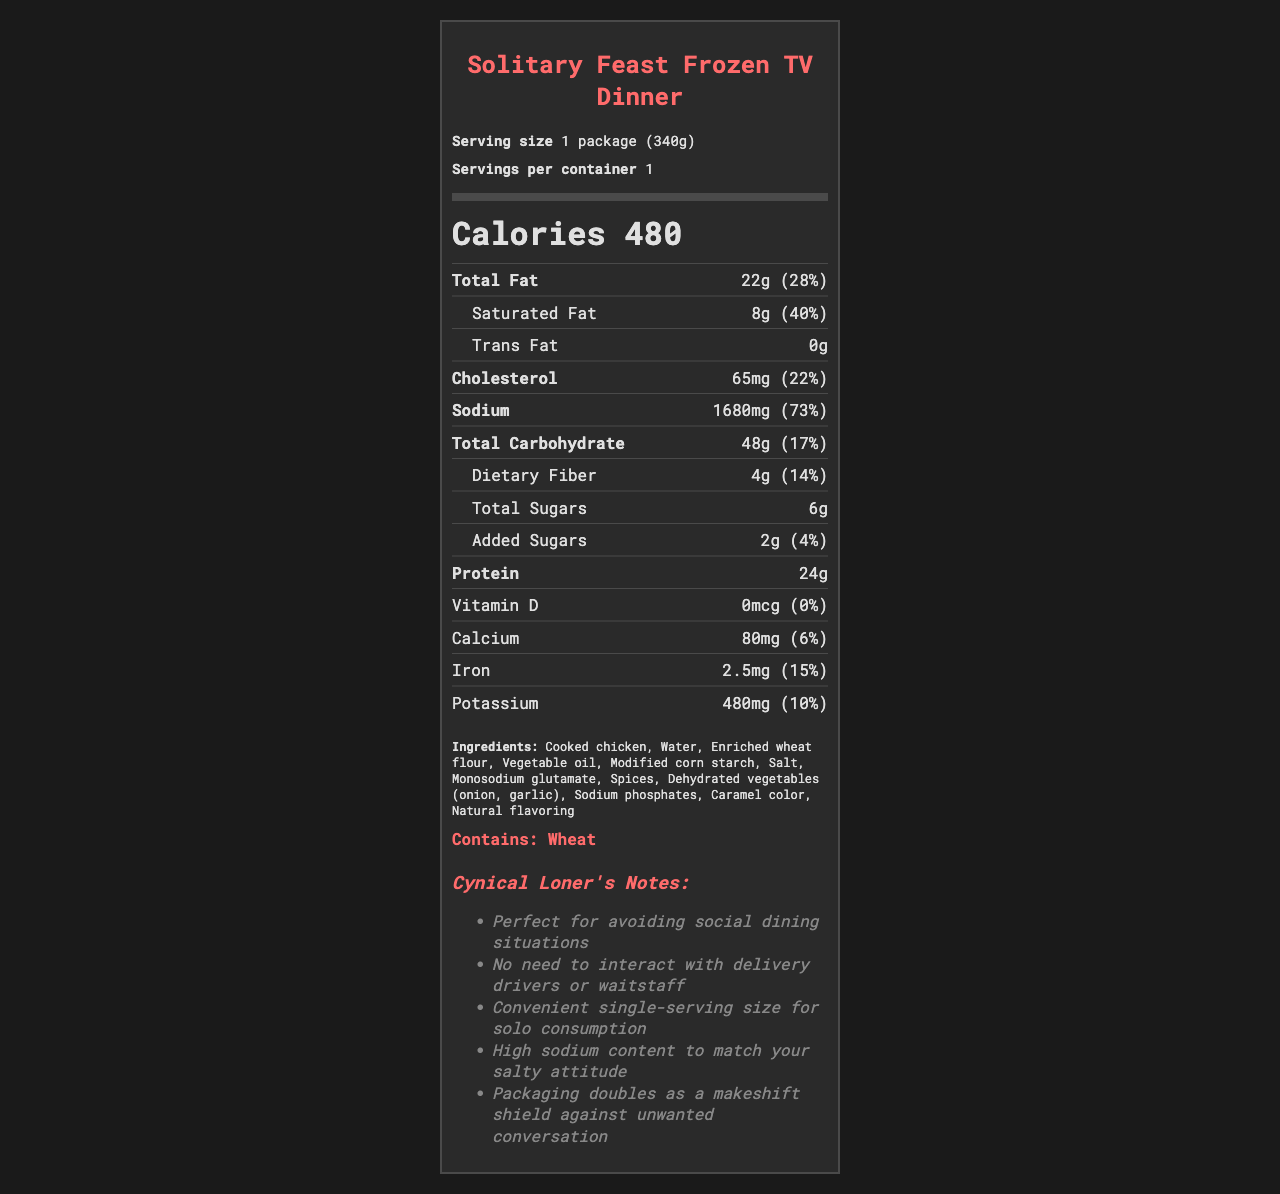what is the serving size of the Solitary Feast Frozen TV Dinner? The serving size is written clearly as "1 package (340g)" at the top of the document.
Answer: 1 package (340g) How many calories are in one serving of this product? Under the "Calories" section, it's explicitly mentioned that there are 480 calories per serving.
Answer: 480 Name two primary ingredients in this frozen TV dinner. The ingredients list shows "Cooked chicken" and "Water" as two of the primary components.
Answer: Cooked chicken, water What is the daily value percentage for cholesterol? The document lists 65mg of cholesterol with a daily value percentage of 22%.
Answer: 22% Does this product contain any trans fat? The label indicates "Trans Fat 0g", which means there is no trans fat in the product.
Answer: No Which nutrient has the highest daily value percentage in this product? Among all the listed nutrients, sodium has the highest daily value percentage at 73%.
Answer: Sodium Which of the following best describes the sodium content in one serving? A. 73mg B. 680mg C. 1680mg D. 48g The document shows that the sodium content is 1680mg, and the daily value percentage is 73%.
Answer: C What allergens are present in this product? A. Milk B. Wheat C. Soy D. Eggs The document specifically mentions "Contains: Wheat" under the allergens section.
Answer: B Does this product contain any Vitamin D? The nutrient section clearly states "Vitamin D 0mcg (0%)", meaning no Vitamin D is present.
Answer: No Summarize the overall nutritional profile of the Solitary Feast Frozen TV Dinner. The summary is derived from the comprehensive information provided, including calorie content, key nutrients, ingredients, and the notes targeting a cynical loner.
Answer: This frozen TV dinner has a high sodium content, significant amounts of total and saturated fat, and provides 480 calories per serving. It is primarily composed of cooked chicken and water, with a few added sugars. The packaging emphasizes the convenience and solitude aspect, notable for those avoiding social dining situations. What preservatives are used in this product? The document lists several ingredients, but it does not specify if any preservatives are used. Thus, this information is not available based on the provided visual data.
Answer: Cannot be determined 